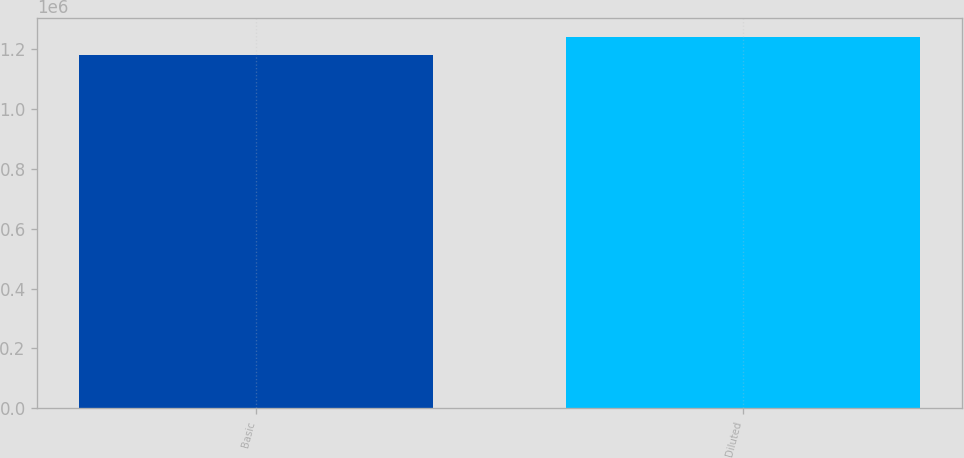<chart> <loc_0><loc_0><loc_500><loc_500><bar_chart><fcel>Basic<fcel>Diluted<nl><fcel>1.18168e+06<fcel>1.2422e+06<nl></chart> 